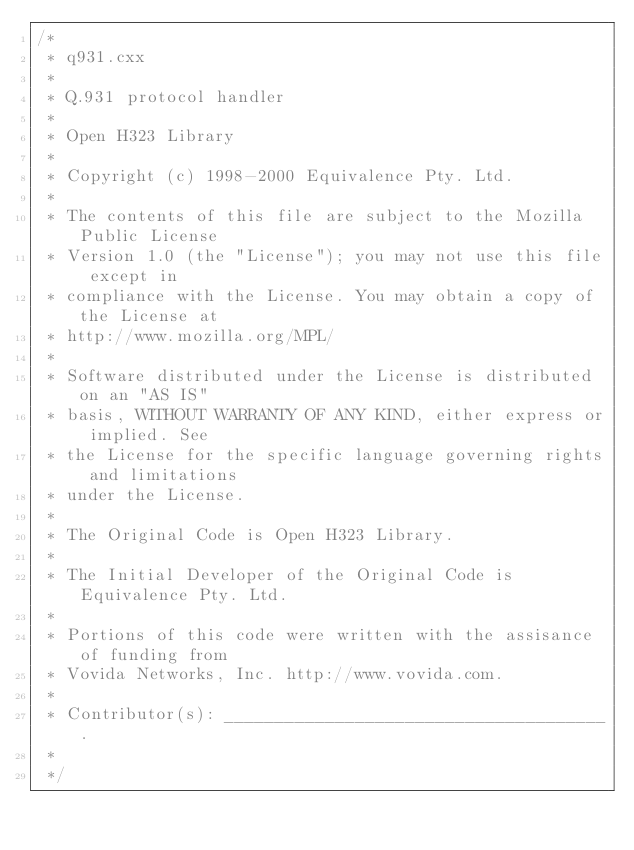Convert code to text. <code><loc_0><loc_0><loc_500><loc_500><_C++_>/*
 * q931.cxx
 *
 * Q.931 protocol handler
 *
 * Open H323 Library
 *
 * Copyright (c) 1998-2000 Equivalence Pty. Ltd.
 *
 * The contents of this file are subject to the Mozilla Public License
 * Version 1.0 (the "License"); you may not use this file except in
 * compliance with the License. You may obtain a copy of the License at
 * http://www.mozilla.org/MPL/
 *
 * Software distributed under the License is distributed on an "AS IS"
 * basis, WITHOUT WARRANTY OF ANY KIND, either express or implied. See
 * the License for the specific language governing rights and limitations
 * under the License.
 *
 * The Original Code is Open H323 Library.
 *
 * The Initial Developer of the Original Code is Equivalence Pty. Ltd.
 *
 * Portions of this code were written with the assisance of funding from
 * Vovida Networks, Inc. http://www.vovida.com.
 *
 * Contributor(s): ______________________________________.
 *
 */
</code> 